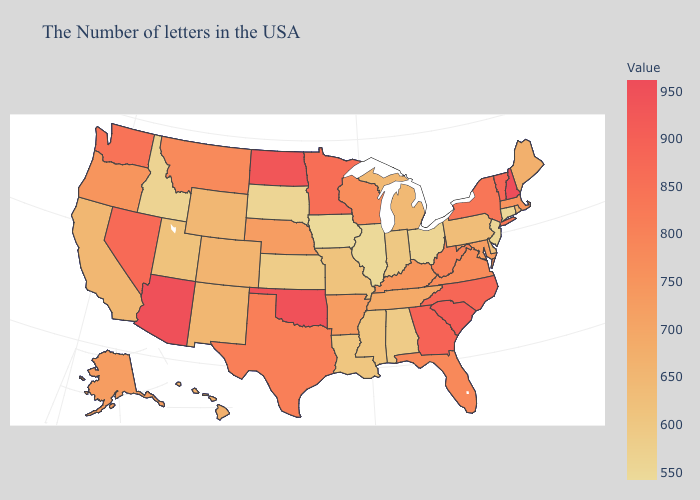Does Nevada have a lower value than Tennessee?
Give a very brief answer. No. Does Iowa have the lowest value in the USA?
Keep it brief. Yes. 